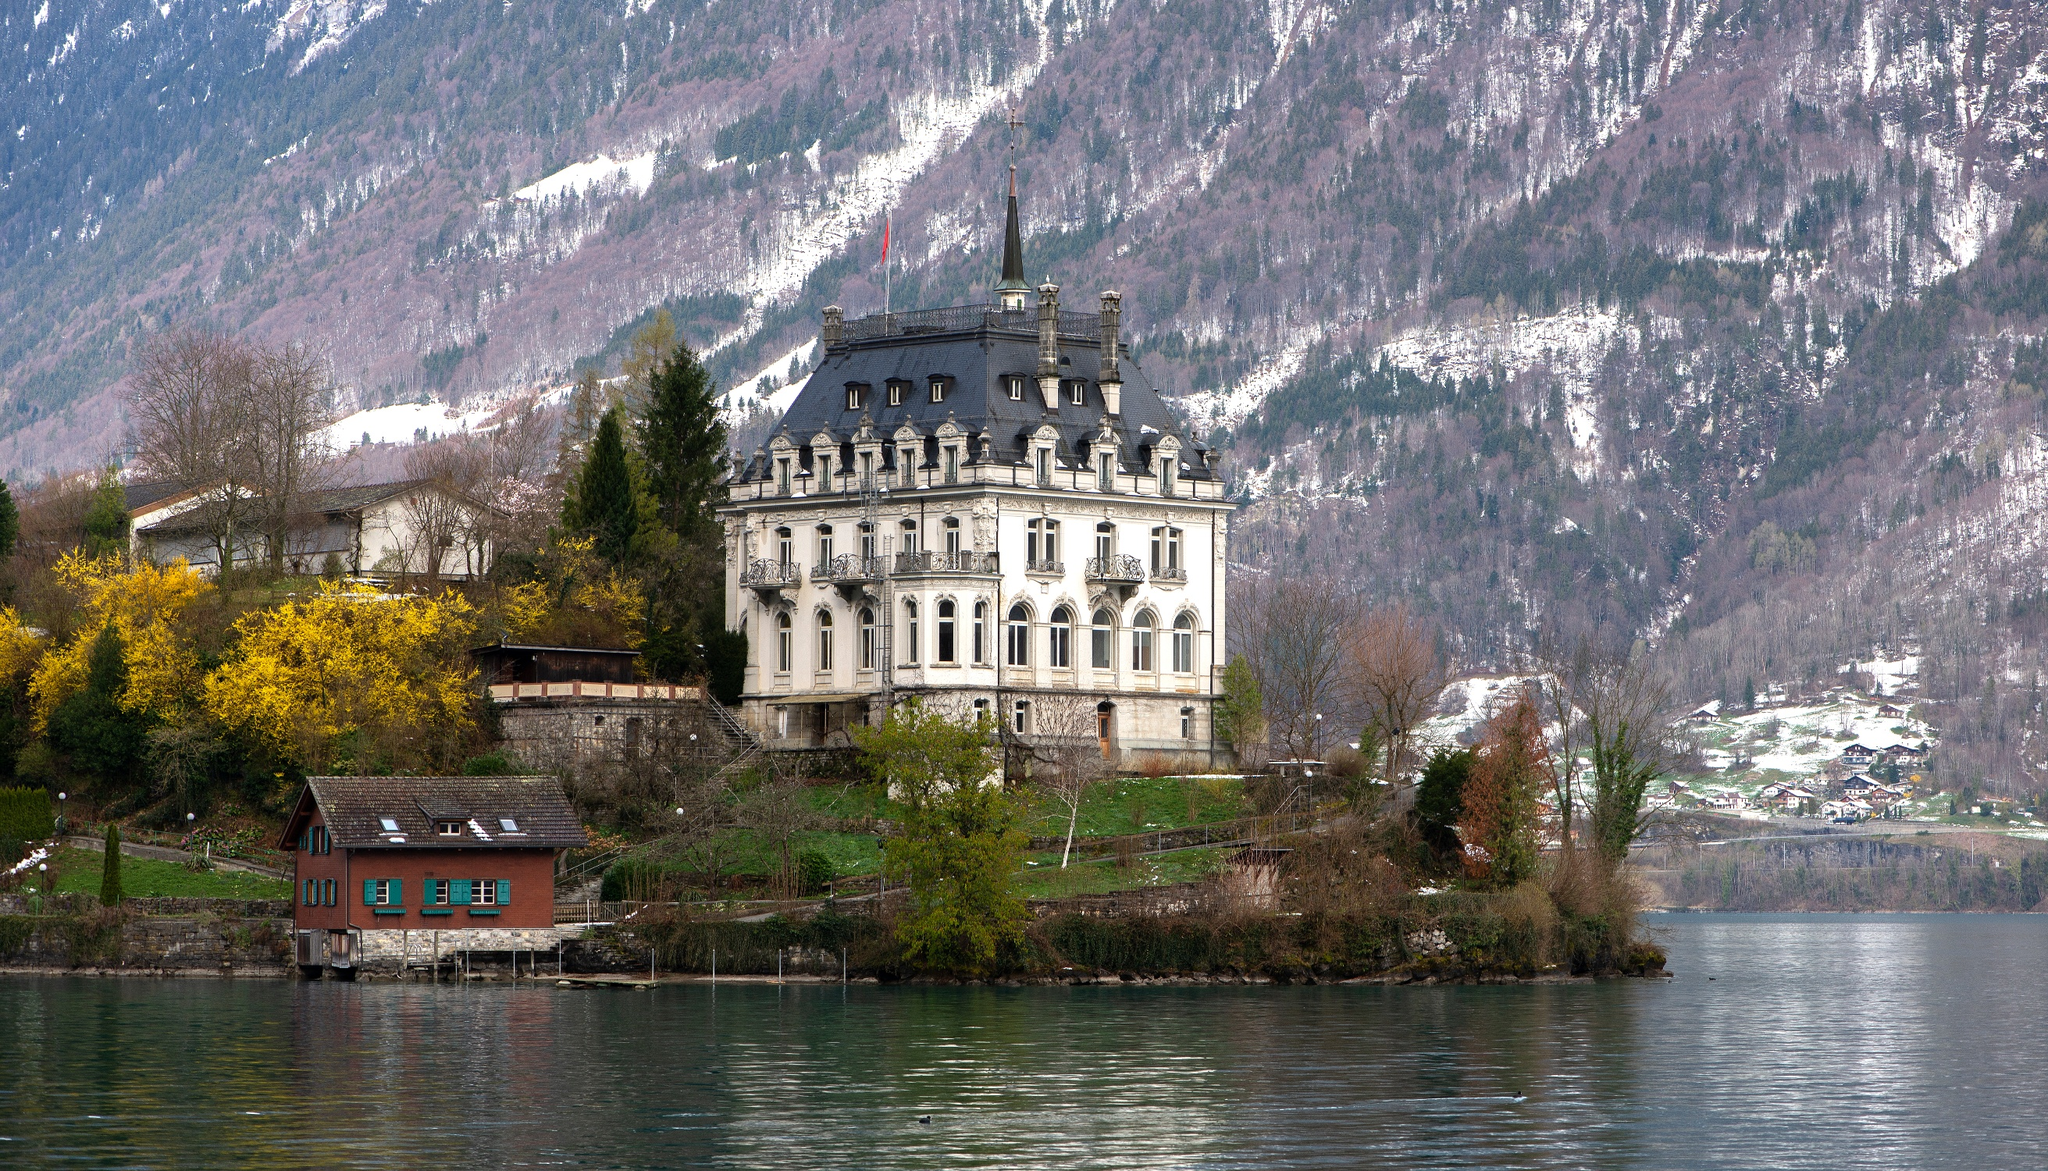Can you describe the atmosphere and ambiance of this place? The atmosphere around Iseltwald Castle is serene and picturesque. The tranquil waters of Lake Brienz reflect a scene of natural beauty, blending seamlessly with the surrounding greenery and the grandeur of the carefully preserved castle. The distant snow-capped mountains add a sense of majesty and calm to the entire setting. The gentle rustling of the trees and the occasional chirping of birds contribute to a peaceful ambiance, making it a perfect spot for relaxation and reflection. What stories or legends might be associated with this place? Iseltwald Castle, like many ancient castles, is likely steeped in stories and legends. One can imagine tales of noble families who once resided here, their lives interwoven with the ebb and flow of regional history. Perhaps there are whispered rumors of hidden treasures or secret passageways within its walls. Legends of heroic feats and romantic escapades might have unfolded amidst its elegant architecture. The surrounding lake might be rumored to hold the spirits of the past, with tales of mystical sightings on moonlit nights. Each stone of Iseltwald Castle could tell a story, echoing the rich heritage and the fascinating mysteries of its bygone eras. If you could spend a day here, what would you do? Spending a day at Iseltwald Castle would be a dream come true! I would start the morning with a leisurely stroll around the castle grounds, soaking in the peaceful ambiance and the stunning views of Lake Brienz. Midday, I'd enjoy a picnic near the shore, savoring some local Swiss delicacies while gazing at the snow-capped mountains in the background. In the afternoon, a guided tour of the castle would be fascinating, uncovering the history, architecture, and stories associated with the heritage site. Finally, as the sun sets, I would find a cozy spot to sit back and watch the changing colors of the sky reflected on the lake, embracing the tranquility and beauty that Iseltwald Castle offers. 